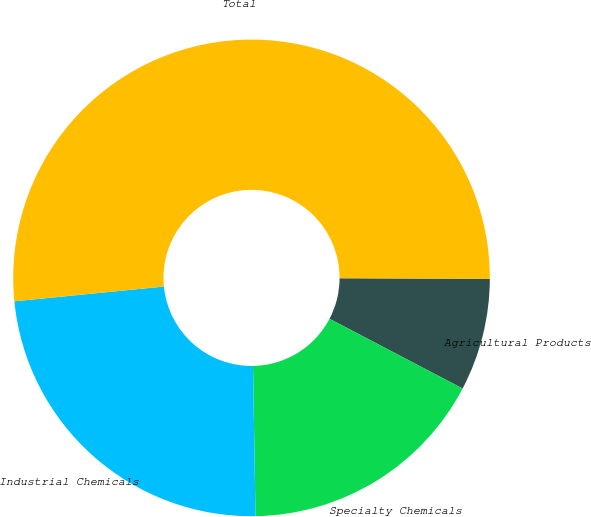<chart> <loc_0><loc_0><loc_500><loc_500><pie_chart><fcel>Agricultural Products<fcel>Specialty Chemicals<fcel>Industrial Chemicals<fcel>Total<nl><fcel>7.62%<fcel>17.05%<fcel>23.7%<fcel>51.63%<nl></chart> 